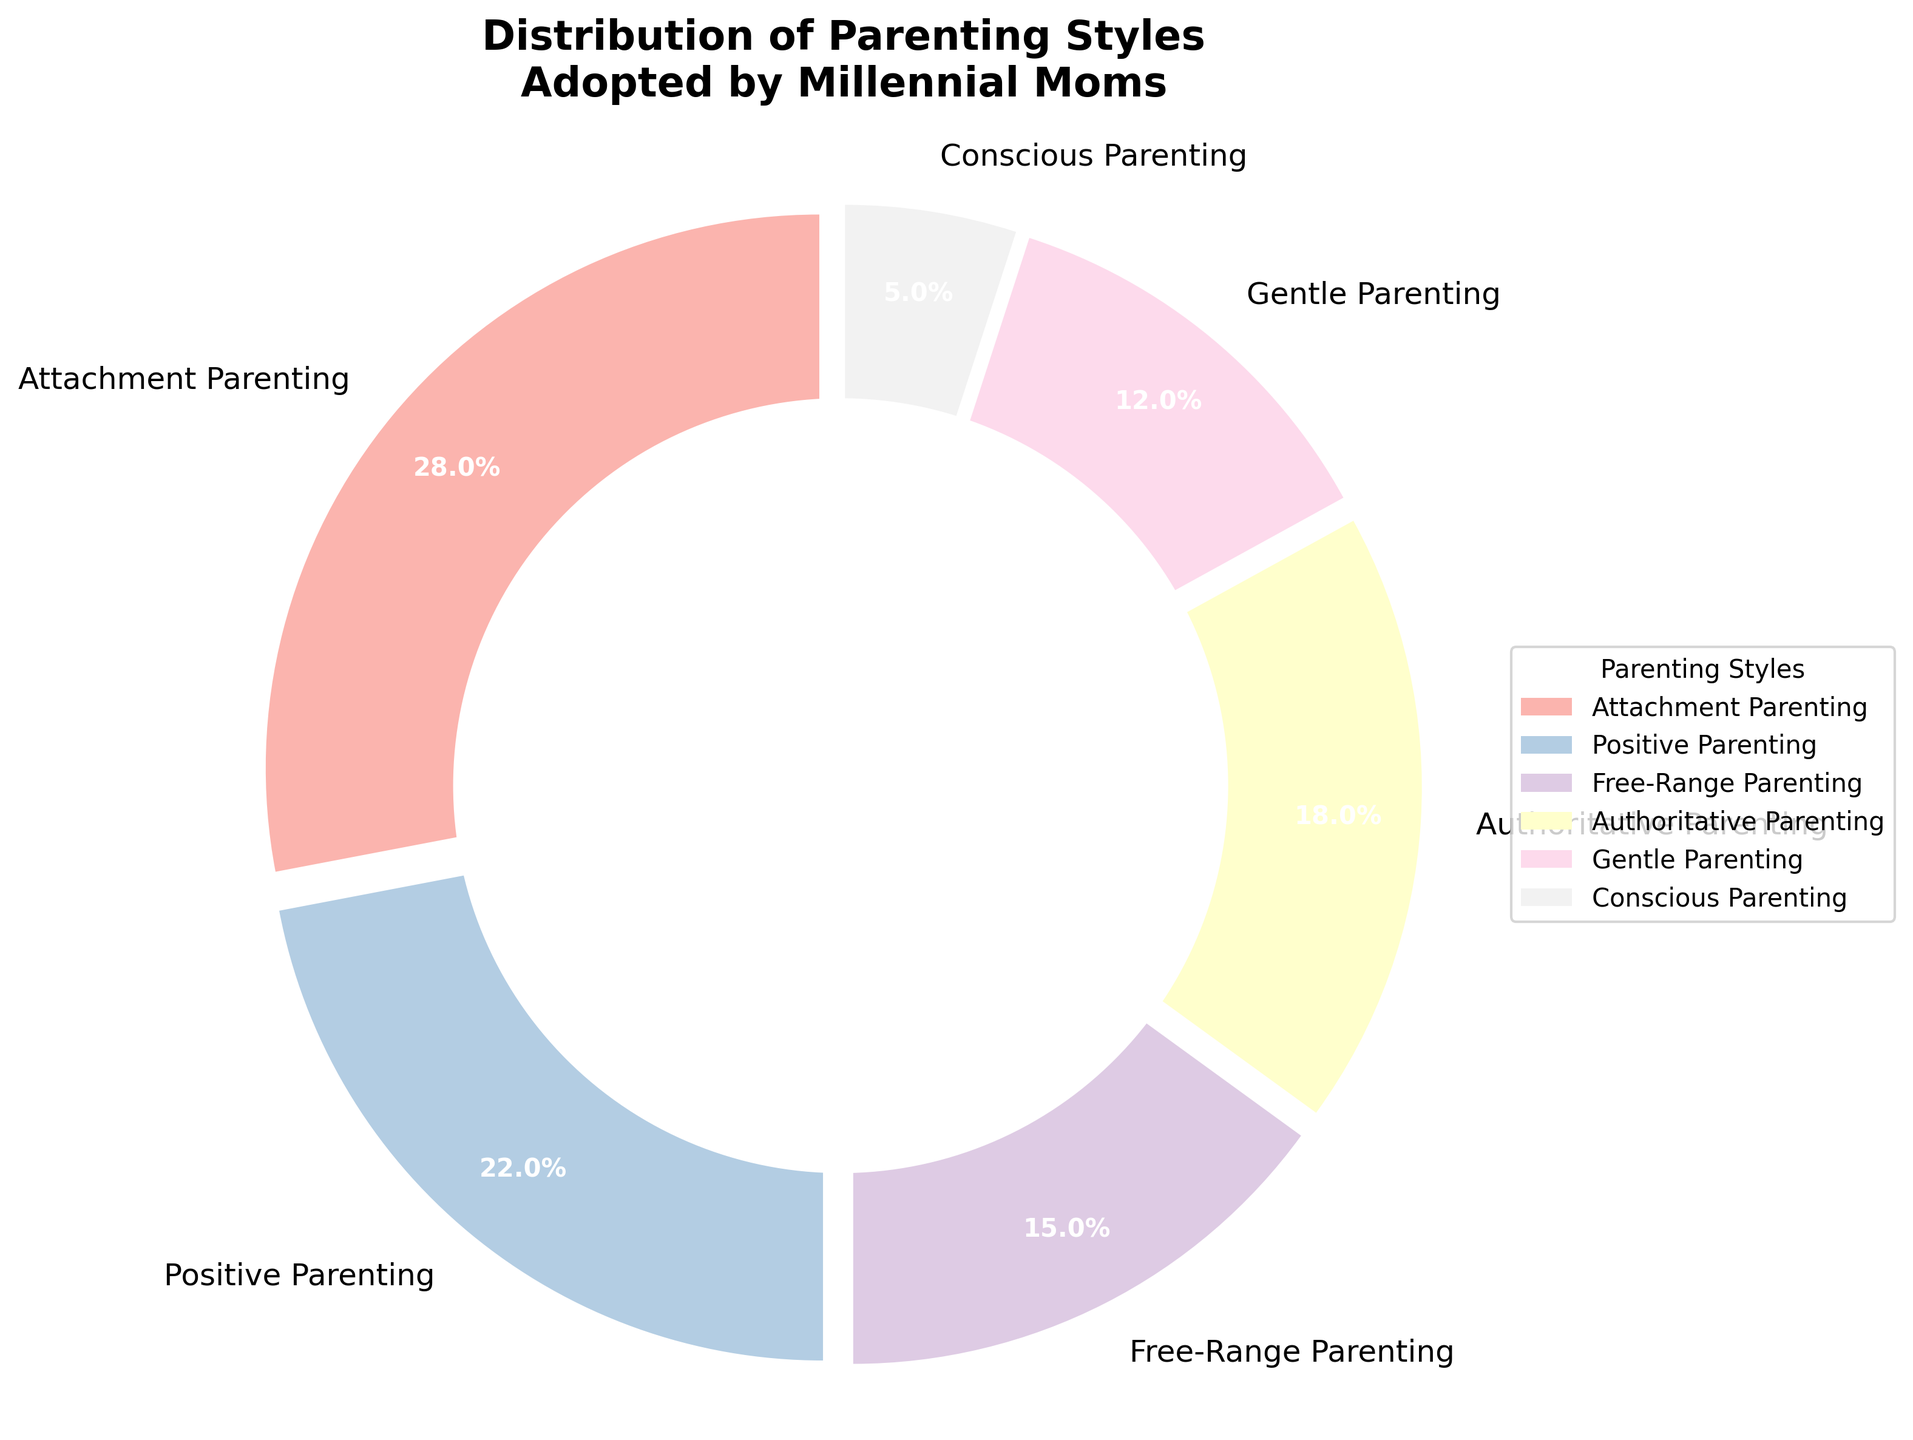Which parenting style is the most commonly adopted by millennial moms? The largest segment in the pie chart represents the most common parenting style. The label with the highest percentage, 28%, is Attachment Parenting.
Answer: Attachment Parenting Which parenting style is the least commonly adopted by millennial moms? The smallest segment in the pie chart represents the least common parenting style. The label with the lowest percentage, 5%, is Conscious Parenting.
Answer: Conscious Parenting What's the difference in percentage between the most and least commonly adopted parenting styles? The most common style is Attachment Parenting at 28%, and the least common style is Conscious Parenting at 5%. The difference is calculated as 28% - 5% = 23%.
Answer: 23% Are there more moms practicing Positive Parenting or Authoritative Parenting? By comparing the percentages, Positive Parenting accounts for 22% while Authoritative Parenting accounts for 18%. Therefore, there are more moms practicing Positive Parenting.
Answer: Positive Parenting Which two parenting styles have similar adoption rates among millennial moms? By examining the pie chart, Positive Parenting (22%) and Authoritative Parenting (18%) have relatively close percentages.
Answer: Positive Parenting and Authoritative Parenting What percentage of millennial moms practice either Attachment Parenting or Gentle Parenting? Adding the percentages of Attachment Parenting (28%) and Gentle Parenting (12%) gives 28% + 12% = 40%.
Answer: 40% What's the cumulative percentage of moms practicing Free-Range Parenting and Conscious Parenting? Adding the percentages of Free-Range Parenting (15%) and Conscious Parenting (5%) gives 15% + 5% = 20%.
Answer: 20% Is the percentage of moms practicing Authoritative Parenting greater than those practicing Gentle Parenting? By comparing the percentages, Authoritative Parenting is 18%, while Gentle Parenting is 12%. Thus, a greater percentage of moms practice Authoritative Parenting.
Answer: Yes Which segment in the pie chart is represented with the color white towards the center? The pie chart has a central circle colored white to create a donut shape, which covers the center of all segments equally. This does not correspond to any specific segment.
Answer: Center circle Is there a parenting style adopted by more than a quarter of millennial moms? Attachment Parenting is adopted by 28% of millennial moms, which is more than a quarter (25%).
Answer: Yes 